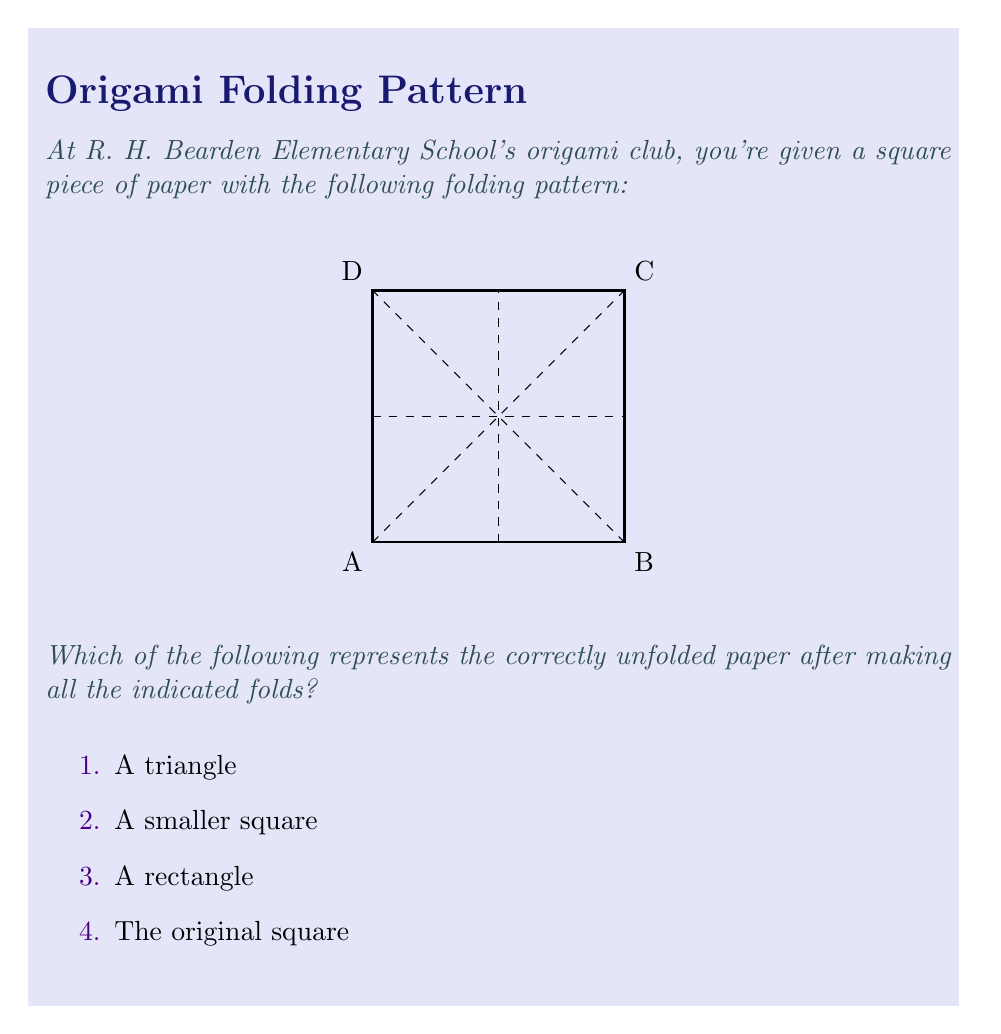Can you answer this question? Let's analyze this step-by-step:

1) The square paper has four dashed lines:
   - A horizontal line through the middle
   - A vertical line through the middle
   - Two diagonal lines from corner to corner

2) These dashed lines represent fold lines.

3) The horizontal and vertical lines divide the square into four equal smaller squares.

4) The diagonal lines, when folded, would bring each corner to the center of the square.

5) When all these folds are made simultaneously:
   - Each corner (A, B, C, D) would be folded to the center.
   - This results in a smaller square formed by the four corners meeting at the center.

6) Therefore, when unfolded, the paper would return to its original square shape, with crease lines visible where the folds were made.

7) None of the folds cut or remove any part of the paper, so the overall shape and size remain unchanged.
Answer: 4. The original square 